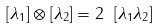<formula> <loc_0><loc_0><loc_500><loc_500>[ \lambda _ { 1 } ] \otimes [ \lambda _ { 2 } ] = 2 \ [ \lambda _ { 1 } \lambda _ { 2 } ]</formula> 